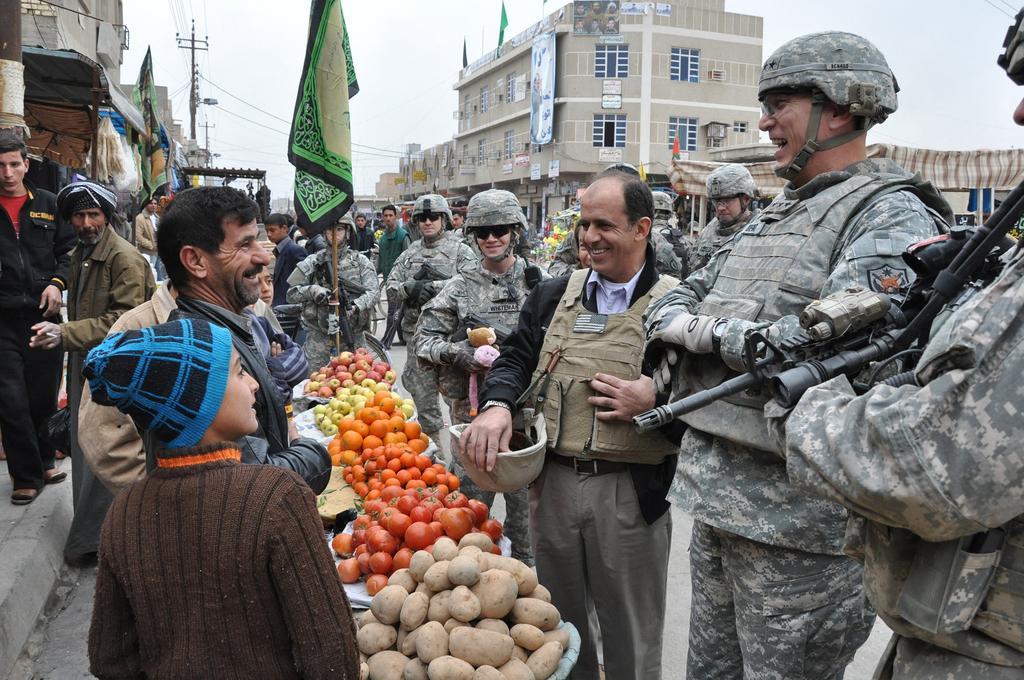Describe this image in one or two sentences. On the left side, there are persons standing in front of vegetables and fruits arranged on the bowls. On the right side, there are persons smiling and standing on the road, some of them are holding guns. In the background, there are persons on the road, there are buildings, pole which is having electrical lines and there is sky. 